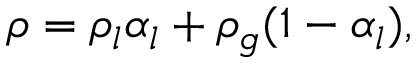<formula> <loc_0><loc_0><loc_500><loc_500>\rho = \rho _ { l } \alpha _ { l } + \rho _ { g } ( 1 - \alpha _ { l } ) ,</formula> 